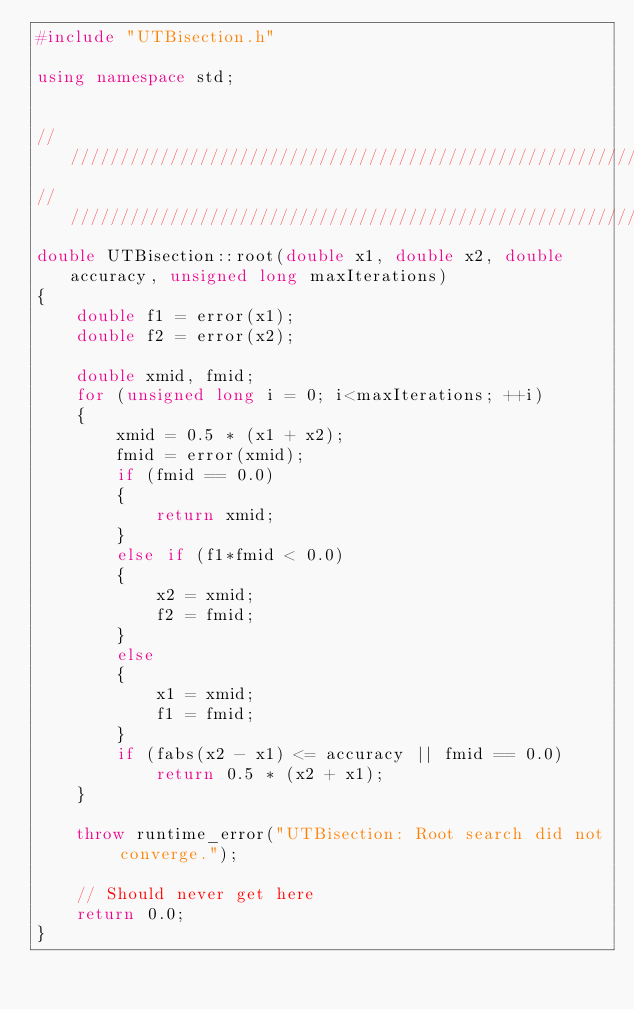<code> <loc_0><loc_0><loc_500><loc_500><_C++_>#include "UTBisection.h"

using namespace std;


///////////////////////////////////////////////////////////////////////////////
///////////////////////////////////////////////////////////////////////////////
double UTBisection::root(double x1, double x2, double accuracy, unsigned long maxIterations)
{
	double f1 = error(x1);
	double f2 = error(x2);

	double xmid, fmid;
	for (unsigned long i = 0; i<maxIterations; ++i)
	{
		xmid = 0.5 * (x1 + x2);
		fmid = error(xmid);
		if (fmid == 0.0)
		{
			return xmid;
		}
		else if (f1*fmid < 0.0)
		{
			x2 = xmid;
			f2 = fmid;
		}
		else
		{
			x1 = xmid;
			f1 = fmid;
		}
		if (fabs(x2 - x1) <= accuracy || fmid == 0.0)
			return 0.5 * (x2 + x1);
	}

	throw runtime_error("UTBisection: Root search did not converge.");

	// Should never get here
	return 0.0;
}
</code> 